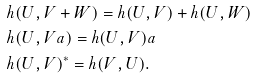<formula> <loc_0><loc_0><loc_500><loc_500>& h ( U , V + W ) = h ( U , V ) + h ( U , W ) \\ & h ( U , V a ) = h ( U , V ) a \\ & h ( U , V ) ^ { \ast } = h ( V , U ) .</formula> 